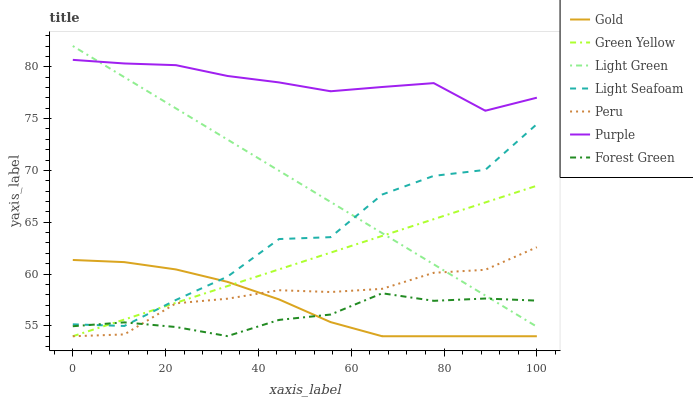Does Forest Green have the minimum area under the curve?
Answer yes or no. Yes. Does Purple have the maximum area under the curve?
Answer yes or no. Yes. Does Light Green have the minimum area under the curve?
Answer yes or no. No. Does Light Green have the maximum area under the curve?
Answer yes or no. No. Is Light Green the smoothest?
Answer yes or no. Yes. Is Light Seafoam the roughest?
Answer yes or no. Yes. Is Gold the smoothest?
Answer yes or no. No. Is Gold the roughest?
Answer yes or no. No. Does Green Yellow have the lowest value?
Answer yes or no. Yes. Does Light Green have the lowest value?
Answer yes or no. No. Does Light Green have the highest value?
Answer yes or no. Yes. Does Gold have the highest value?
Answer yes or no. No. Is Gold less than Light Green?
Answer yes or no. Yes. Is Purple greater than Gold?
Answer yes or no. Yes. Does Green Yellow intersect Gold?
Answer yes or no. Yes. Is Green Yellow less than Gold?
Answer yes or no. No. Is Green Yellow greater than Gold?
Answer yes or no. No. Does Gold intersect Light Green?
Answer yes or no. No. 